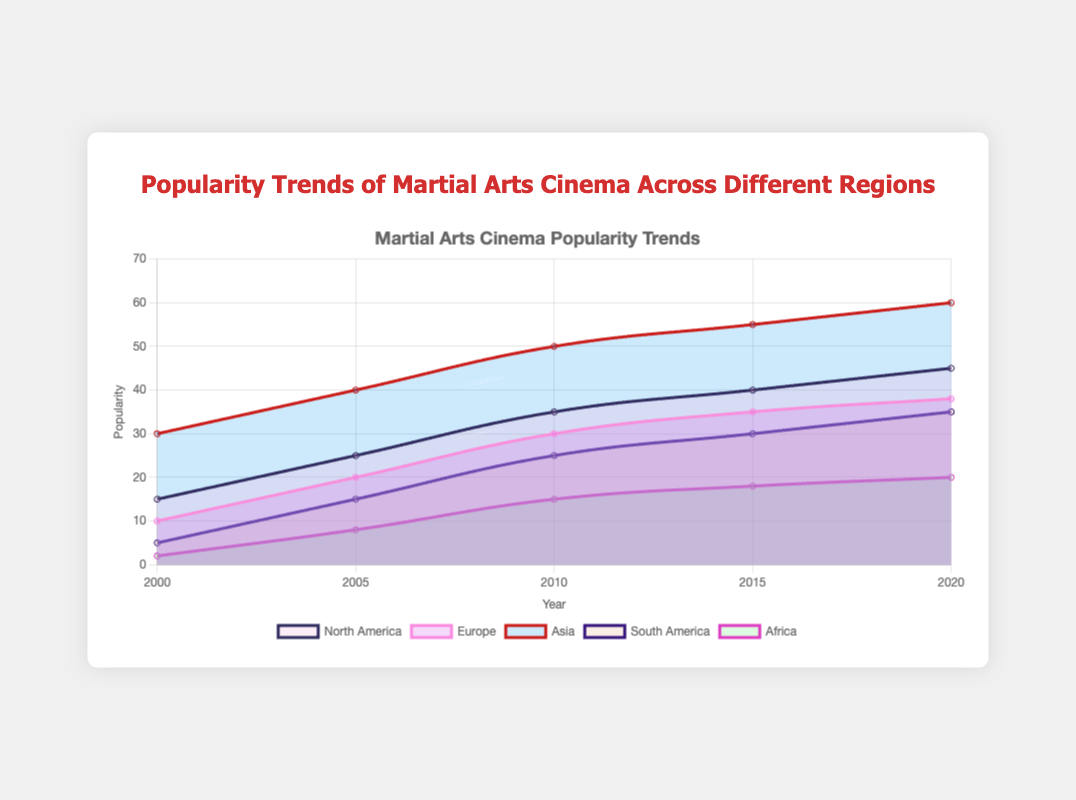What is the title of the figure? The title of the figure is displayed at the top and is clearly visible as "Popularity Trends of Martial Arts Cinema Across Different Regions."
Answer: Popularity Trends of Martial Arts Cinema Across Different Regions How many regions are compared in the chart? By looking at the legend at the bottom, we can see that five regions are compared in the chart: North America, Europe, Asia, South America, and Africa.
Answer: Five Which region had the highest popularity in martial arts cinema in 2020? According to the data points for 2020, Asia had the highest popularity, with a value of 60.
Answer: Asia What was the popularity of martial arts cinema in North America in 2000? Referring to the data point for North America in the year 2000, the popularity value is 15.
Answer: 15 Which region had the lowest popularity in martial arts cinema in 2000? By comparing the popularity values in 2000 among all regions, Africa had the lowest popularity with a value of 2.
Answer: Africa Between 2005 and 2010, which region experienced the largest increase in popularity? To determine this, we calculate the difference in popularity for each region between 2005 and 2010: North America (35-25=10), Europe (30-20=10), Asia (50-40=10), South America (25-15=10), Africa (15-8=7). All regions except Africa had an increase of 10, so there is a tie between North America, Europe, Asia, and South America.
Answer: North America, Europe, Asia, South America What trends can you observe about the popularity of martial arts cinema in Africa from 2000 to 2020? From the chart, we can see that the popularity in Africa gradually increased: 2 in 2000, 8 in 2005, 15 in 2010, 18 in 2015, and 20 in 2020, indicating a steady upward trend over the years.
Answer: Steady increase How much did the popularity of martial arts cinema in Europe increase from 2000 to 2020? By subtracting the popularity value of Europe in 2000 (10) from the value in 2020 (38), we get an increase of 28.
Answer: 28 Which regions showed a consistent rise in popularity from 2000 to 2020? Regions with a consistent rise in popularity across the years (no year with a drop) are North America, Europe, Asia, South America, and Africa. Each region's popularity values increase monotonically over the years.
Answer: All regions What is the average popularity of martial arts cinema in South America from 2000 to 2020? To calculate the average, sum up the popularity values for South America across all years (5 + 15 + 25 + 30 + 35 = 110) and divide by the number of years (5). The average is 110/5 = 22.
Answer: 22 